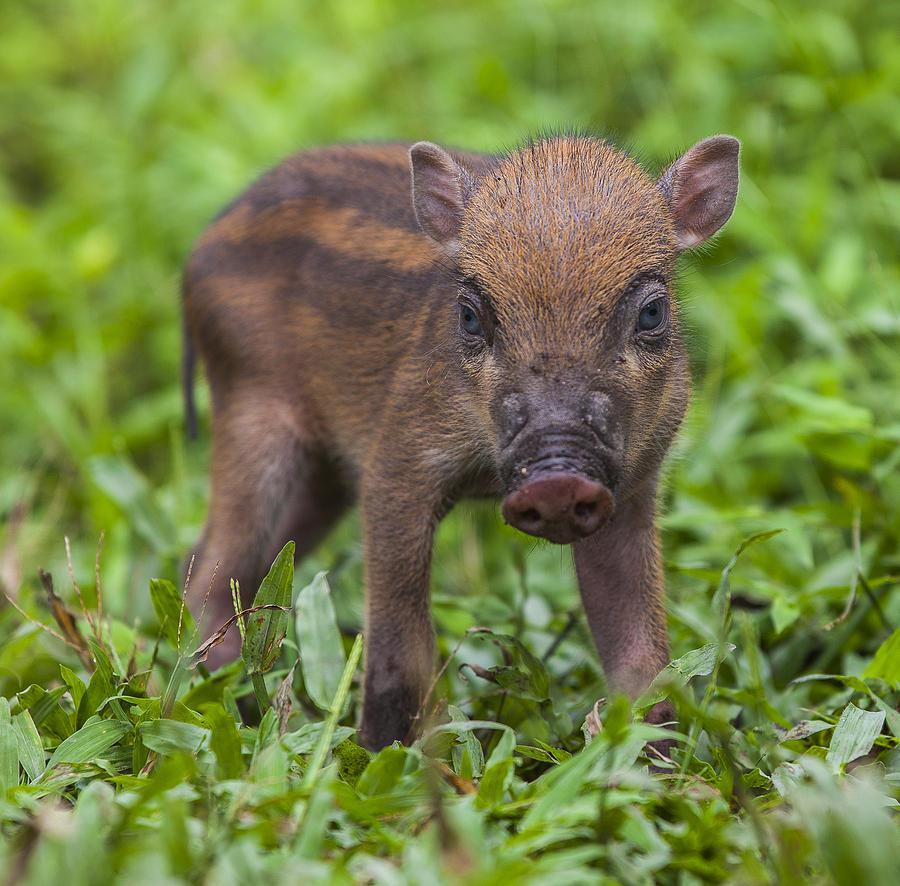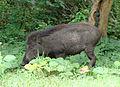The first image is the image on the left, the second image is the image on the right. Evaluate the accuracy of this statement regarding the images: "Each image includes at least one piglet with distinctive beige and brown stripes standing in profile on all fours.". Is it true? Answer yes or no. No. 